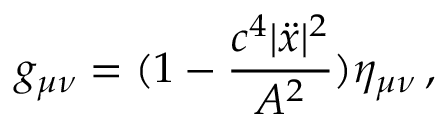<formula> <loc_0><loc_0><loc_500><loc_500>g _ { \mu \nu } = ( 1 - \frac { c ^ { 4 } | \ddot { x } | ^ { 2 } } { A ^ { 2 } } ) \eta _ { \mu \nu } \, { , }</formula> 